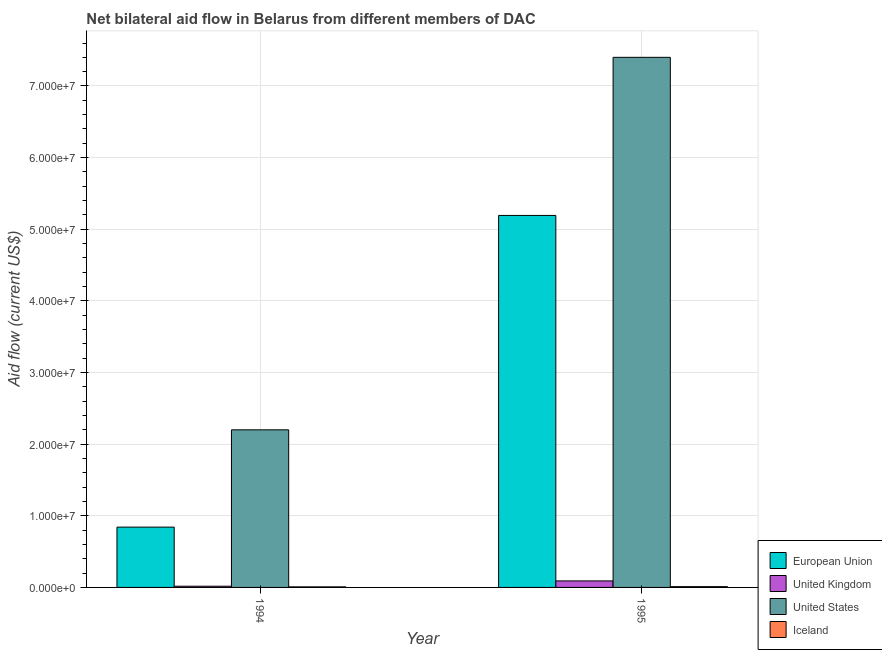How many groups of bars are there?
Your response must be concise. 2. In how many cases, is the number of bars for a given year not equal to the number of legend labels?
Give a very brief answer. 0. What is the amount of aid given by iceland in 1995?
Ensure brevity in your answer.  1.10e+05. Across all years, what is the maximum amount of aid given by us?
Ensure brevity in your answer.  7.40e+07. Across all years, what is the minimum amount of aid given by uk?
Provide a short and direct response. 1.70e+05. In which year was the amount of aid given by us minimum?
Your answer should be compact. 1994. What is the total amount of aid given by uk in the graph?
Your response must be concise. 1.08e+06. What is the difference between the amount of aid given by uk in 1994 and that in 1995?
Provide a succinct answer. -7.40e+05. What is the difference between the amount of aid given by eu in 1995 and the amount of aid given by iceland in 1994?
Provide a short and direct response. 4.35e+07. What is the average amount of aid given by iceland per year?
Make the answer very short. 9.50e+04. What is the ratio of the amount of aid given by iceland in 1994 to that in 1995?
Keep it short and to the point. 0.73. Is the amount of aid given by iceland in 1994 less than that in 1995?
Your response must be concise. Yes. Is it the case that in every year, the sum of the amount of aid given by us and amount of aid given by uk is greater than the sum of amount of aid given by iceland and amount of aid given by eu?
Your response must be concise. Yes. What does the 2nd bar from the right in 1994 represents?
Your answer should be compact. United States. Are all the bars in the graph horizontal?
Your answer should be very brief. No. How many years are there in the graph?
Provide a succinct answer. 2. What is the difference between two consecutive major ticks on the Y-axis?
Your answer should be compact. 1.00e+07. Are the values on the major ticks of Y-axis written in scientific E-notation?
Provide a short and direct response. Yes. Does the graph contain grids?
Keep it short and to the point. Yes. How are the legend labels stacked?
Ensure brevity in your answer.  Vertical. What is the title of the graph?
Give a very brief answer. Net bilateral aid flow in Belarus from different members of DAC. What is the label or title of the X-axis?
Ensure brevity in your answer.  Year. What is the Aid flow (current US$) of European Union in 1994?
Your answer should be compact. 8.42e+06. What is the Aid flow (current US$) of United States in 1994?
Provide a short and direct response. 2.20e+07. What is the Aid flow (current US$) in Iceland in 1994?
Your response must be concise. 8.00e+04. What is the Aid flow (current US$) in European Union in 1995?
Give a very brief answer. 5.19e+07. What is the Aid flow (current US$) of United Kingdom in 1995?
Make the answer very short. 9.10e+05. What is the Aid flow (current US$) in United States in 1995?
Offer a terse response. 7.40e+07. Across all years, what is the maximum Aid flow (current US$) in European Union?
Give a very brief answer. 5.19e+07. Across all years, what is the maximum Aid flow (current US$) in United Kingdom?
Your response must be concise. 9.10e+05. Across all years, what is the maximum Aid flow (current US$) in United States?
Offer a terse response. 7.40e+07. Across all years, what is the minimum Aid flow (current US$) in European Union?
Keep it short and to the point. 8.42e+06. Across all years, what is the minimum Aid flow (current US$) in United States?
Your answer should be very brief. 2.20e+07. What is the total Aid flow (current US$) in European Union in the graph?
Provide a short and direct response. 6.04e+07. What is the total Aid flow (current US$) of United Kingdom in the graph?
Ensure brevity in your answer.  1.08e+06. What is the total Aid flow (current US$) of United States in the graph?
Offer a very short reply. 9.60e+07. What is the difference between the Aid flow (current US$) in European Union in 1994 and that in 1995?
Provide a short and direct response. -4.35e+07. What is the difference between the Aid flow (current US$) in United Kingdom in 1994 and that in 1995?
Your answer should be compact. -7.40e+05. What is the difference between the Aid flow (current US$) of United States in 1994 and that in 1995?
Your response must be concise. -5.20e+07. What is the difference between the Aid flow (current US$) of Iceland in 1994 and that in 1995?
Your response must be concise. -3.00e+04. What is the difference between the Aid flow (current US$) of European Union in 1994 and the Aid flow (current US$) of United Kingdom in 1995?
Provide a short and direct response. 7.51e+06. What is the difference between the Aid flow (current US$) in European Union in 1994 and the Aid flow (current US$) in United States in 1995?
Provide a short and direct response. -6.56e+07. What is the difference between the Aid flow (current US$) of European Union in 1994 and the Aid flow (current US$) of Iceland in 1995?
Provide a succinct answer. 8.31e+06. What is the difference between the Aid flow (current US$) in United Kingdom in 1994 and the Aid flow (current US$) in United States in 1995?
Offer a terse response. -7.38e+07. What is the difference between the Aid flow (current US$) in United Kingdom in 1994 and the Aid flow (current US$) in Iceland in 1995?
Provide a short and direct response. 6.00e+04. What is the difference between the Aid flow (current US$) of United States in 1994 and the Aid flow (current US$) of Iceland in 1995?
Ensure brevity in your answer.  2.19e+07. What is the average Aid flow (current US$) in European Union per year?
Provide a short and direct response. 3.02e+07. What is the average Aid flow (current US$) in United Kingdom per year?
Give a very brief answer. 5.40e+05. What is the average Aid flow (current US$) in United States per year?
Offer a terse response. 4.80e+07. What is the average Aid flow (current US$) in Iceland per year?
Your response must be concise. 9.50e+04. In the year 1994, what is the difference between the Aid flow (current US$) in European Union and Aid flow (current US$) in United Kingdom?
Provide a succinct answer. 8.25e+06. In the year 1994, what is the difference between the Aid flow (current US$) in European Union and Aid flow (current US$) in United States?
Make the answer very short. -1.36e+07. In the year 1994, what is the difference between the Aid flow (current US$) in European Union and Aid flow (current US$) in Iceland?
Your response must be concise. 8.34e+06. In the year 1994, what is the difference between the Aid flow (current US$) in United Kingdom and Aid flow (current US$) in United States?
Your answer should be compact. -2.18e+07. In the year 1994, what is the difference between the Aid flow (current US$) of United States and Aid flow (current US$) of Iceland?
Offer a terse response. 2.19e+07. In the year 1995, what is the difference between the Aid flow (current US$) of European Union and Aid flow (current US$) of United Kingdom?
Keep it short and to the point. 5.10e+07. In the year 1995, what is the difference between the Aid flow (current US$) of European Union and Aid flow (current US$) of United States?
Your response must be concise. -2.21e+07. In the year 1995, what is the difference between the Aid flow (current US$) of European Union and Aid flow (current US$) of Iceland?
Offer a very short reply. 5.18e+07. In the year 1995, what is the difference between the Aid flow (current US$) of United Kingdom and Aid flow (current US$) of United States?
Ensure brevity in your answer.  -7.31e+07. In the year 1995, what is the difference between the Aid flow (current US$) of United Kingdom and Aid flow (current US$) of Iceland?
Offer a very short reply. 8.00e+05. In the year 1995, what is the difference between the Aid flow (current US$) in United States and Aid flow (current US$) in Iceland?
Your answer should be compact. 7.39e+07. What is the ratio of the Aid flow (current US$) in European Union in 1994 to that in 1995?
Ensure brevity in your answer.  0.16. What is the ratio of the Aid flow (current US$) of United Kingdom in 1994 to that in 1995?
Provide a short and direct response. 0.19. What is the ratio of the Aid flow (current US$) in United States in 1994 to that in 1995?
Your answer should be compact. 0.3. What is the ratio of the Aid flow (current US$) of Iceland in 1994 to that in 1995?
Provide a succinct answer. 0.73. What is the difference between the highest and the second highest Aid flow (current US$) in European Union?
Keep it short and to the point. 4.35e+07. What is the difference between the highest and the second highest Aid flow (current US$) in United Kingdom?
Provide a succinct answer. 7.40e+05. What is the difference between the highest and the second highest Aid flow (current US$) of United States?
Your response must be concise. 5.20e+07. What is the difference between the highest and the lowest Aid flow (current US$) in European Union?
Your answer should be compact. 4.35e+07. What is the difference between the highest and the lowest Aid flow (current US$) in United Kingdom?
Offer a terse response. 7.40e+05. What is the difference between the highest and the lowest Aid flow (current US$) in United States?
Your response must be concise. 5.20e+07. 